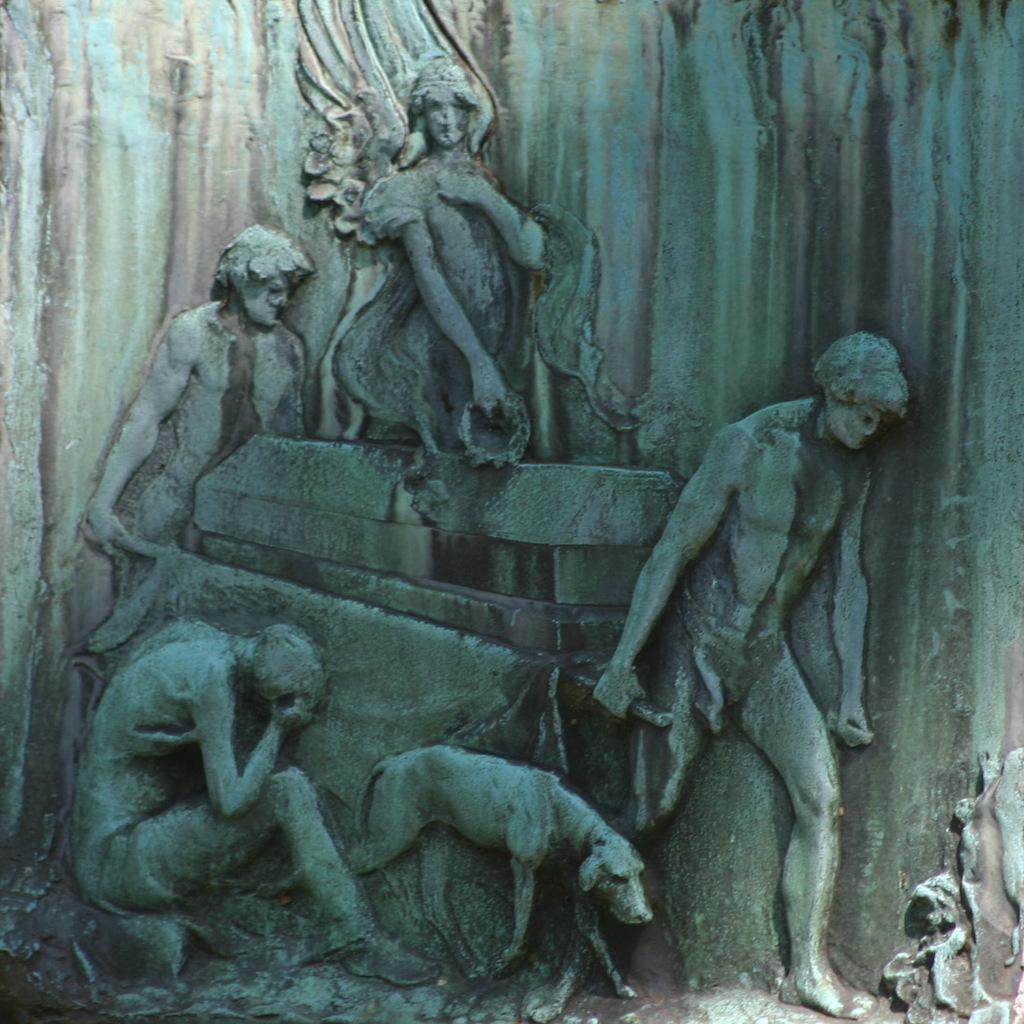Please provide a concise description of this image. In this image we can see some sculptures on a stone. 